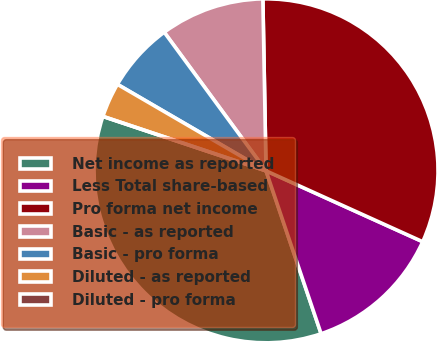Convert chart to OTSL. <chart><loc_0><loc_0><loc_500><loc_500><pie_chart><fcel>Net income as reported<fcel>Less Total share-based<fcel>Pro forma net income<fcel>Basic - as reported<fcel>Basic - pro forma<fcel>Diluted - as reported<fcel>Diluted - pro forma<nl><fcel>35.32%<fcel>13.05%<fcel>32.06%<fcel>9.79%<fcel>6.53%<fcel>3.26%<fcel>0.0%<nl></chart> 